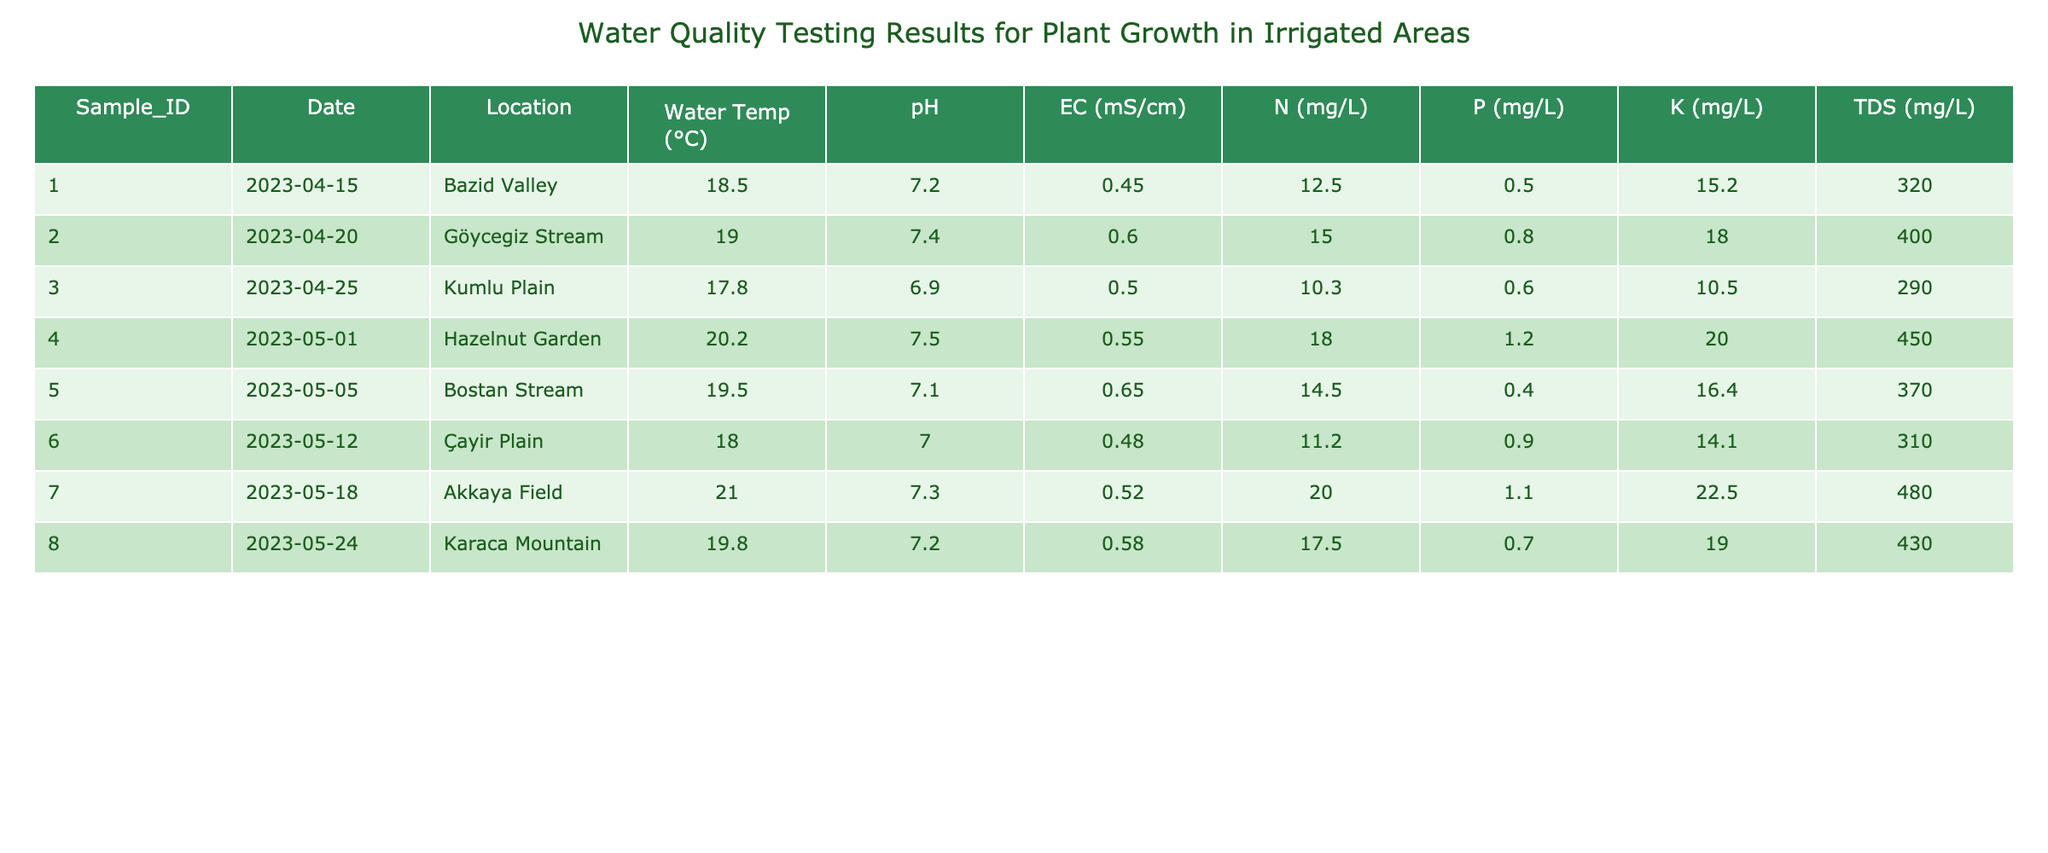What is the pH level of the water sample collected from the Kumlu Plain? The pH level for the Kumlu Plain is listed in the table under the corresponding row (Sample_ID 003). It shows a pH level of 6.9.
Answer: 6.9 Which water sample had the highest nitrogen content? By comparing the nitrogen content across all samples, we find that Sample_ID 007 from Akkaya Field has 20.0 mg/L, which is the highest value among all listed samples.
Answer: 20.0 mg/L What is the average electrical conductivity of the water samples in the table? The values of electrical conductivity (EC) are: 0.45, 0.60, 0.50, 0.55, 0.65, 0.48, 0.52, and 0.58 mS/cm. Adding these gives 4.33, and dividing by the number of samples (8) gives an average of 0.54 mS/cm.
Answer: 0.54 mS/cm Is the total dissolved solids (TDS) level in the water sample from Bostan Stream greater than 350 mg/L? The TDS value for Bostan Stream (Sample_ID 005) is 370 mg/L. Since this is greater than 350 mg/L, the answer is yes.
Answer: Yes What is the difference in phosphorus content between the water sample from Hazelnut Garden and that from Akkaya Field? Hazelnut Garden has a phosphorus level of 1.2 mg/L (Sample_ID 004) and Akkaya Field has 1.1 mg/L (Sample_ID 007). The difference is 1.2 - 1.1 = 0.1 mg/L.
Answer: 0.1 mg/L Which location had the highest water temperature, and what was the value? Looking at the Water Temperature column, Akkaya Field (Sample_ID 007) shows a temperature of 21.0°C which is the highest reading compared to the other locations.
Answer: 21.0°C Are all the samples taken during the month of April? Samples 001, 002, and 003 were collected in April, while Samples 004, 005, 006, 007, and 008 were collected in May. Therefore, not all samples were taken in April.
Answer: No Calculate the average potassium content across all samples. The potassium contents are: 15.2, 18.0, 10.5, 20.0, 16.4, 14.1, 22.5, and 19.0 mg/L. Adding these values gives 135.7 mg/L, and dividing by 8 samples gives an average of 16.96 mg/L.
Answer: 16.96 mg/L 